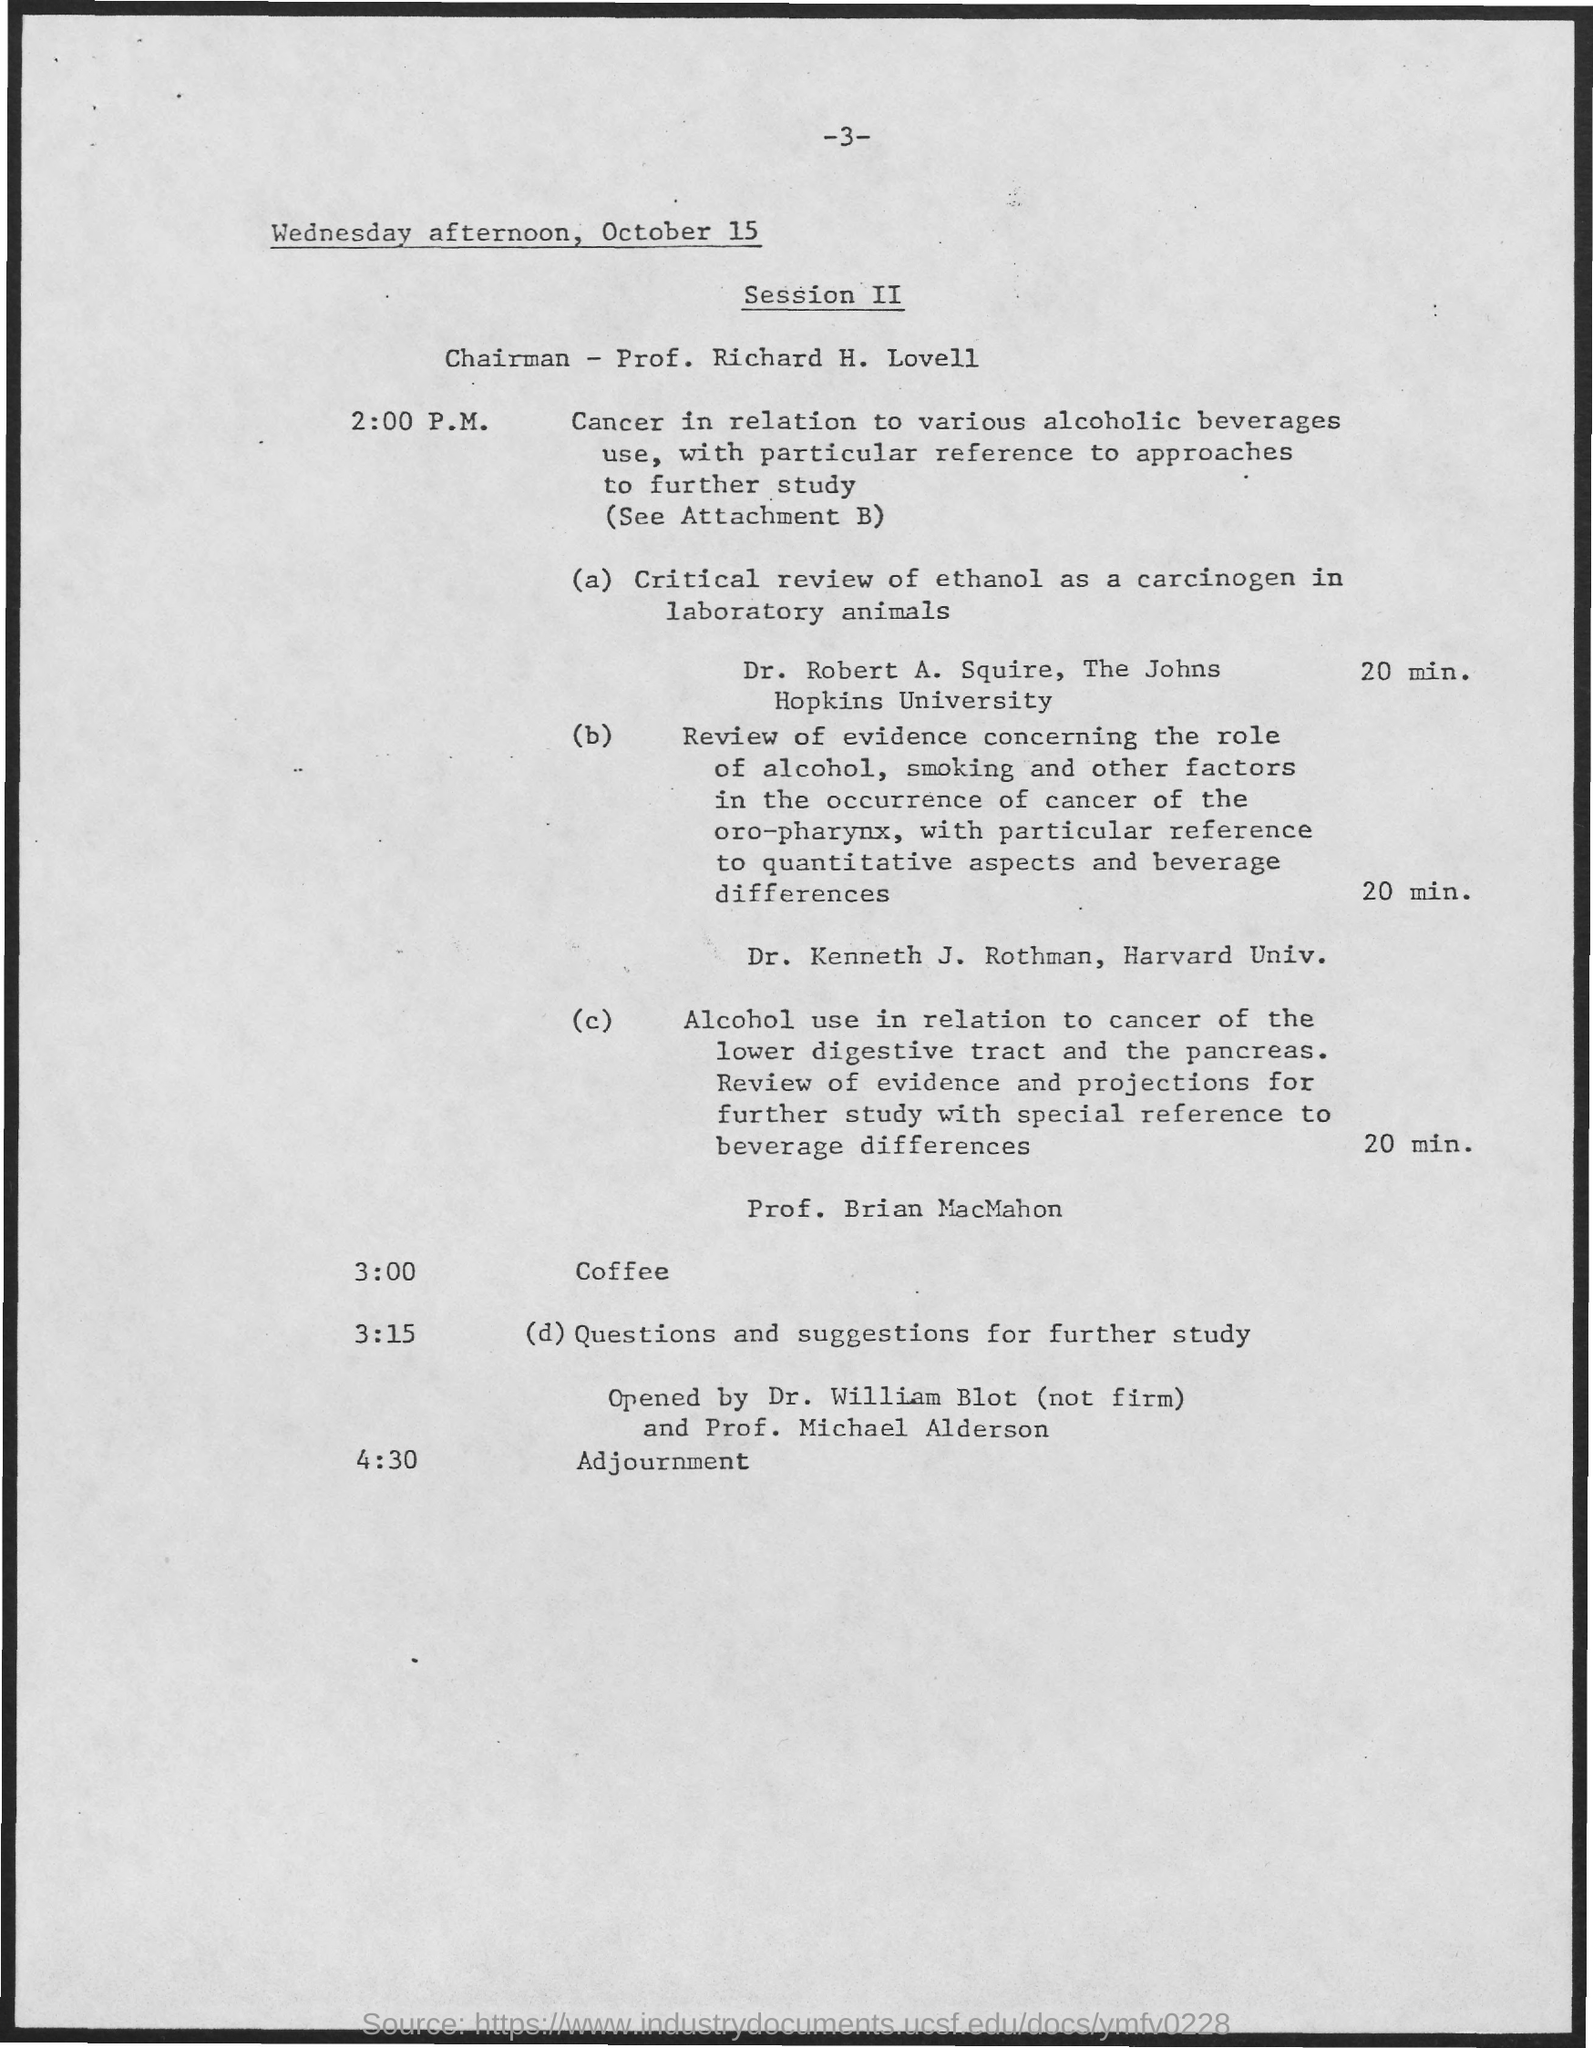What event is scheduled for 4:30?
Provide a short and direct response. Adjournment. Who is the Chairman of the Session II?
Give a very brief answer. Prof. Richard H. Lovell. What is scheduled at 3:00?
Offer a terse response. Coffee. 